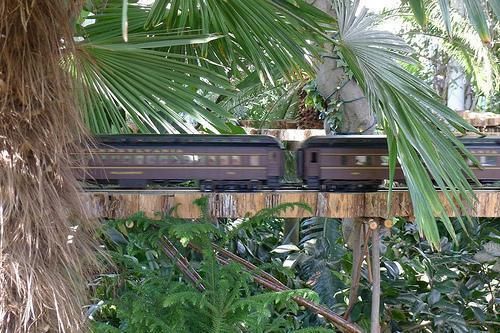How many trains are there?
Give a very brief answer. 1. How many train cars are visible?
Give a very brief answer. 2. 